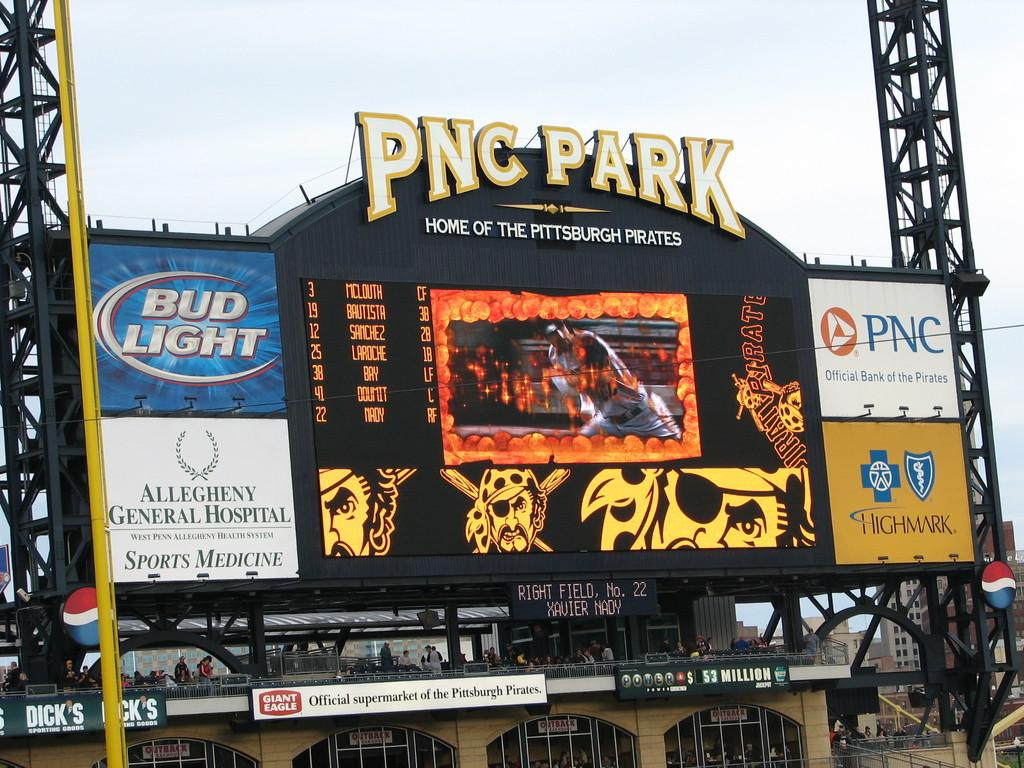<image>
Share a concise interpretation of the image provided. scoreboard at pnc park where the pittsburgh pirates play baseball 